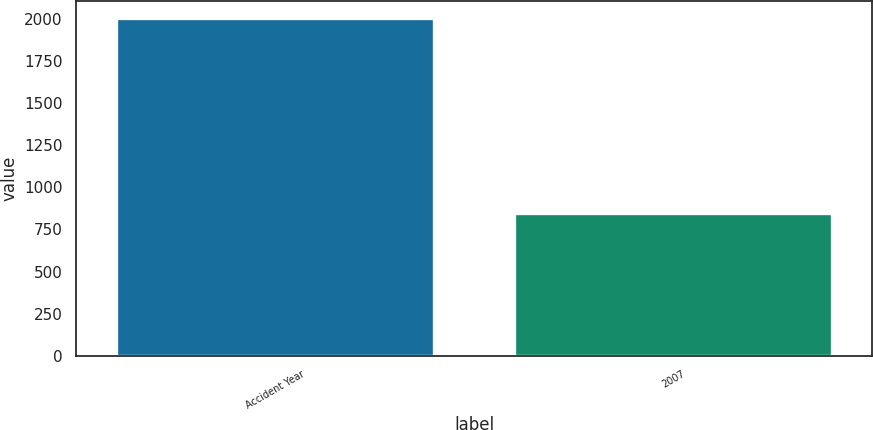Convert chart. <chart><loc_0><loc_0><loc_500><loc_500><bar_chart><fcel>Accident Year<fcel>2007<nl><fcel>2008<fcel>846<nl></chart> 